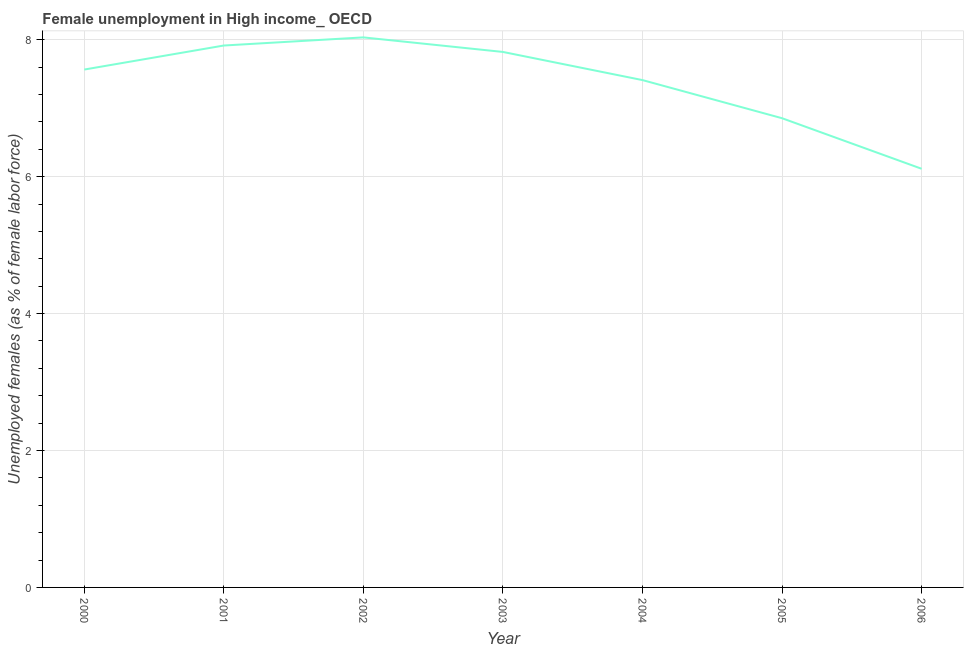What is the unemployed females population in 2002?
Keep it short and to the point. 8.03. Across all years, what is the maximum unemployed females population?
Your response must be concise. 8.03. Across all years, what is the minimum unemployed females population?
Your answer should be compact. 6.12. In which year was the unemployed females population minimum?
Offer a very short reply. 2006. What is the sum of the unemployed females population?
Offer a terse response. 51.71. What is the difference between the unemployed females population in 2000 and 2006?
Give a very brief answer. 1.45. What is the average unemployed females population per year?
Ensure brevity in your answer.  7.39. What is the median unemployed females population?
Keep it short and to the point. 7.56. Do a majority of the years between 2004 and 2002 (inclusive) have unemployed females population greater than 7.2 %?
Give a very brief answer. No. What is the ratio of the unemployed females population in 2005 to that in 2006?
Your answer should be compact. 1.12. Is the difference between the unemployed females population in 2000 and 2001 greater than the difference between any two years?
Your answer should be compact. No. What is the difference between the highest and the second highest unemployed females population?
Offer a very short reply. 0.12. Is the sum of the unemployed females population in 2001 and 2004 greater than the maximum unemployed females population across all years?
Your answer should be compact. Yes. What is the difference between the highest and the lowest unemployed females population?
Your response must be concise. 1.92. How many years are there in the graph?
Your response must be concise. 7. What is the difference between two consecutive major ticks on the Y-axis?
Offer a very short reply. 2. Are the values on the major ticks of Y-axis written in scientific E-notation?
Ensure brevity in your answer.  No. Does the graph contain any zero values?
Your response must be concise. No. Does the graph contain grids?
Offer a terse response. Yes. What is the title of the graph?
Your answer should be very brief. Female unemployment in High income_ OECD. What is the label or title of the Y-axis?
Your answer should be very brief. Unemployed females (as % of female labor force). What is the Unemployed females (as % of female labor force) of 2000?
Provide a succinct answer. 7.56. What is the Unemployed females (as % of female labor force) in 2001?
Give a very brief answer. 7.92. What is the Unemployed females (as % of female labor force) of 2002?
Keep it short and to the point. 8.03. What is the Unemployed females (as % of female labor force) of 2003?
Give a very brief answer. 7.82. What is the Unemployed females (as % of female labor force) in 2004?
Your answer should be very brief. 7.41. What is the Unemployed females (as % of female labor force) in 2005?
Provide a short and direct response. 6.85. What is the Unemployed females (as % of female labor force) of 2006?
Keep it short and to the point. 6.12. What is the difference between the Unemployed females (as % of female labor force) in 2000 and 2001?
Your answer should be very brief. -0.35. What is the difference between the Unemployed females (as % of female labor force) in 2000 and 2002?
Make the answer very short. -0.47. What is the difference between the Unemployed females (as % of female labor force) in 2000 and 2003?
Ensure brevity in your answer.  -0.26. What is the difference between the Unemployed females (as % of female labor force) in 2000 and 2004?
Give a very brief answer. 0.15. What is the difference between the Unemployed females (as % of female labor force) in 2000 and 2005?
Offer a terse response. 0.71. What is the difference between the Unemployed females (as % of female labor force) in 2000 and 2006?
Provide a short and direct response. 1.45. What is the difference between the Unemployed females (as % of female labor force) in 2001 and 2002?
Provide a short and direct response. -0.12. What is the difference between the Unemployed females (as % of female labor force) in 2001 and 2003?
Your response must be concise. 0.09. What is the difference between the Unemployed females (as % of female labor force) in 2001 and 2004?
Your answer should be very brief. 0.51. What is the difference between the Unemployed females (as % of female labor force) in 2001 and 2005?
Your response must be concise. 1.06. What is the difference between the Unemployed females (as % of female labor force) in 2001 and 2006?
Give a very brief answer. 1.8. What is the difference between the Unemployed females (as % of female labor force) in 2002 and 2003?
Your response must be concise. 0.21. What is the difference between the Unemployed females (as % of female labor force) in 2002 and 2004?
Give a very brief answer. 0.62. What is the difference between the Unemployed females (as % of female labor force) in 2002 and 2005?
Keep it short and to the point. 1.18. What is the difference between the Unemployed females (as % of female labor force) in 2002 and 2006?
Make the answer very short. 1.92. What is the difference between the Unemployed females (as % of female labor force) in 2003 and 2004?
Provide a succinct answer. 0.41. What is the difference between the Unemployed females (as % of female labor force) in 2003 and 2005?
Offer a terse response. 0.97. What is the difference between the Unemployed females (as % of female labor force) in 2003 and 2006?
Your answer should be very brief. 1.71. What is the difference between the Unemployed females (as % of female labor force) in 2004 and 2005?
Give a very brief answer. 0.56. What is the difference between the Unemployed females (as % of female labor force) in 2004 and 2006?
Provide a succinct answer. 1.3. What is the difference between the Unemployed females (as % of female labor force) in 2005 and 2006?
Your answer should be compact. 0.74. What is the ratio of the Unemployed females (as % of female labor force) in 2000 to that in 2001?
Make the answer very short. 0.96. What is the ratio of the Unemployed females (as % of female labor force) in 2000 to that in 2002?
Make the answer very short. 0.94. What is the ratio of the Unemployed females (as % of female labor force) in 2000 to that in 2003?
Make the answer very short. 0.97. What is the ratio of the Unemployed females (as % of female labor force) in 2000 to that in 2004?
Provide a short and direct response. 1.02. What is the ratio of the Unemployed females (as % of female labor force) in 2000 to that in 2005?
Offer a terse response. 1.1. What is the ratio of the Unemployed females (as % of female labor force) in 2000 to that in 2006?
Provide a short and direct response. 1.24. What is the ratio of the Unemployed females (as % of female labor force) in 2001 to that in 2004?
Keep it short and to the point. 1.07. What is the ratio of the Unemployed females (as % of female labor force) in 2001 to that in 2005?
Provide a short and direct response. 1.16. What is the ratio of the Unemployed females (as % of female labor force) in 2001 to that in 2006?
Provide a short and direct response. 1.29. What is the ratio of the Unemployed females (as % of female labor force) in 2002 to that in 2003?
Your answer should be very brief. 1.03. What is the ratio of the Unemployed females (as % of female labor force) in 2002 to that in 2004?
Your answer should be very brief. 1.08. What is the ratio of the Unemployed females (as % of female labor force) in 2002 to that in 2005?
Your answer should be very brief. 1.17. What is the ratio of the Unemployed females (as % of female labor force) in 2002 to that in 2006?
Offer a terse response. 1.31. What is the ratio of the Unemployed females (as % of female labor force) in 2003 to that in 2004?
Provide a succinct answer. 1.05. What is the ratio of the Unemployed females (as % of female labor force) in 2003 to that in 2005?
Your response must be concise. 1.14. What is the ratio of the Unemployed females (as % of female labor force) in 2003 to that in 2006?
Offer a terse response. 1.28. What is the ratio of the Unemployed females (as % of female labor force) in 2004 to that in 2005?
Offer a terse response. 1.08. What is the ratio of the Unemployed females (as % of female labor force) in 2004 to that in 2006?
Provide a succinct answer. 1.21. What is the ratio of the Unemployed females (as % of female labor force) in 2005 to that in 2006?
Provide a short and direct response. 1.12. 